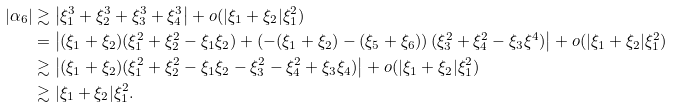<formula> <loc_0><loc_0><loc_500><loc_500>| \alpha _ { 6 } | & \gtrsim \left | \xi _ { 1 } ^ { 3 } + \xi _ { 2 } ^ { 3 } + \xi _ { 3 } ^ { 3 } + \xi _ { 4 } ^ { 3 } \right | + o ( | \xi _ { 1 } + \xi _ { 2 } | \xi _ { 1 } ^ { 2 } ) \\ & = \left | ( \xi _ { 1 } + \xi _ { 2 } ) ( \xi _ { 1 } ^ { 2 } + \xi _ { 2 } ^ { 2 } - \xi _ { 1 } \xi _ { 2 } ) + \left ( - ( \xi _ { 1 } + \xi _ { 2 } ) - ( \xi _ { 5 } + \xi _ { 6 } ) \right ) ( \xi _ { 3 } ^ { 2 } + \xi _ { 4 } ^ { 2 } - \xi _ { 3 } \xi ^ { 4 } ) \right | + o ( | \xi _ { 1 } + \xi _ { 2 } | \xi _ { 1 } ^ { 2 } ) \\ & \gtrsim \left | ( \xi _ { 1 } + \xi _ { 2 } ) ( \xi _ { 1 } ^ { 2 } + \xi _ { 2 } ^ { 2 } - \xi _ { 1 } \xi _ { 2 } - \xi ^ { 2 } _ { 3 } - \xi _ { 4 } ^ { 2 } + \xi _ { 3 } \xi _ { 4 } ) \right | + o ( | \xi _ { 1 } + \xi _ { 2 } | \xi _ { 1 } ^ { 2 } ) \\ & \gtrsim | \xi _ { 1 } + \xi _ { 2 } | \xi _ { 1 } ^ { 2 } .</formula> 